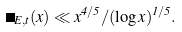<formula> <loc_0><loc_0><loc_500><loc_500>\Pi _ { E , t } ( x ) \ll x ^ { 4 / 5 } / ( \log x ) ^ { 1 / 5 } .</formula> 